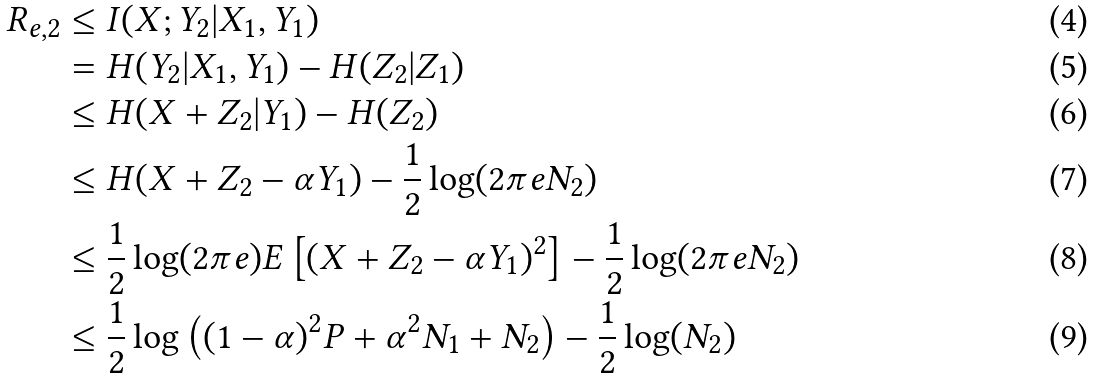Convert formula to latex. <formula><loc_0><loc_0><loc_500><loc_500>R _ { e , 2 } & \leq I ( X ; Y _ { 2 } | X _ { 1 } , Y _ { 1 } ) \\ & = H ( Y _ { 2 } | X _ { 1 } , Y _ { 1 } ) - H ( Z _ { 2 } | Z _ { 1 } ) \\ & \leq H ( X + Z _ { 2 } | Y _ { 1 } ) - H ( Z _ { 2 } ) \\ & \leq H ( X + Z _ { 2 } - \alpha Y _ { 1 } ) - \frac { 1 } { 2 } \log ( 2 \pi e N _ { 2 } ) \\ & \leq \frac { 1 } { 2 } \log ( 2 \pi e ) E \left [ ( X + Z _ { 2 } - \alpha Y _ { 1 } ) ^ { 2 } \right ] - \frac { 1 } { 2 } \log ( 2 \pi e N _ { 2 } ) \\ & \leq \frac { 1 } { 2 } \log \left ( ( 1 - \alpha ) ^ { 2 } P + \alpha ^ { 2 } N _ { 1 } + N _ { 2 } \right ) - \frac { 1 } { 2 } \log ( N _ { 2 } )</formula> 